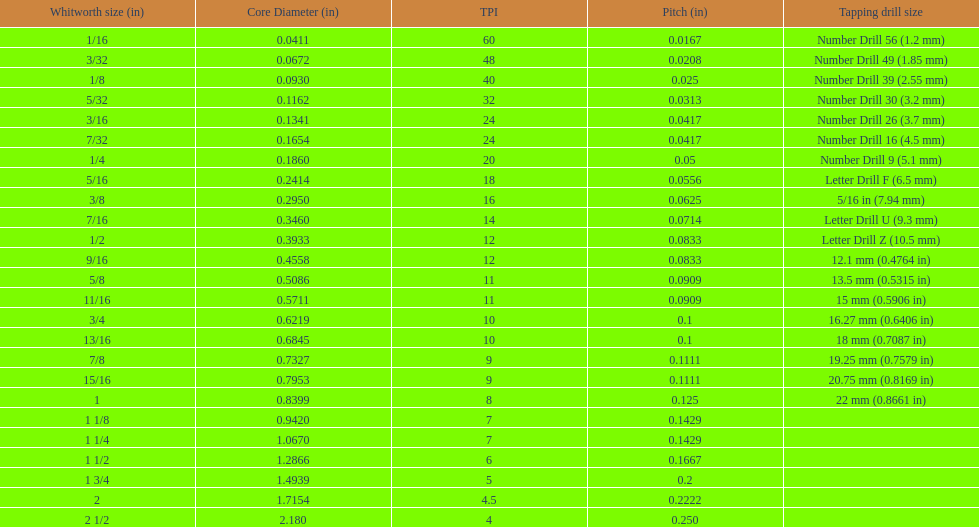What is the next whitworth size (in) below 1/8? 5/32. 